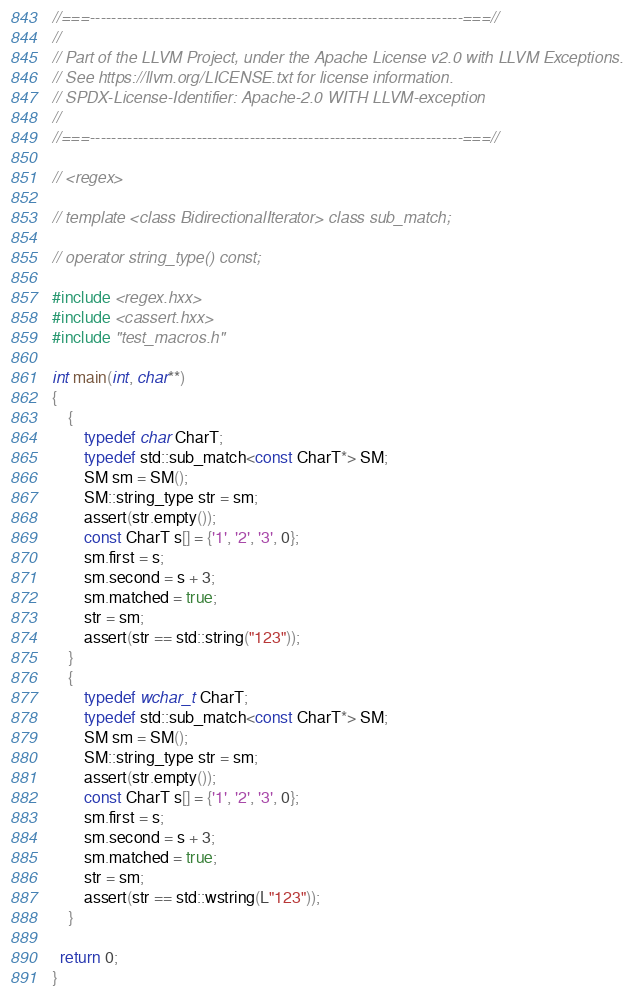<code> <loc_0><loc_0><loc_500><loc_500><_C++_>//===----------------------------------------------------------------------===//
//
// Part of the LLVM Project, under the Apache License v2.0 with LLVM Exceptions.
// See https://llvm.org/LICENSE.txt for license information.
// SPDX-License-Identifier: Apache-2.0 WITH LLVM-exception
//
//===----------------------------------------------------------------------===//

// <regex>

// template <class BidirectionalIterator> class sub_match;

// operator string_type() const;

#include <regex.hxx>
#include <cassert.hxx>
#include "test_macros.h"

int main(int, char**)
{
    {
        typedef char CharT;
        typedef std::sub_match<const CharT*> SM;
        SM sm = SM();
        SM::string_type str = sm;
        assert(str.empty());
        const CharT s[] = {'1', '2', '3', 0};
        sm.first = s;
        sm.second = s + 3;
        sm.matched = true;
        str = sm;
        assert(str == std::string("123"));
    }
    {
        typedef wchar_t CharT;
        typedef std::sub_match<const CharT*> SM;
        SM sm = SM();
        SM::string_type str = sm;
        assert(str.empty());
        const CharT s[] = {'1', '2', '3', 0};
        sm.first = s;
        sm.second = s + 3;
        sm.matched = true;
        str = sm;
        assert(str == std::wstring(L"123"));
    }

  return 0;
}
</code> 